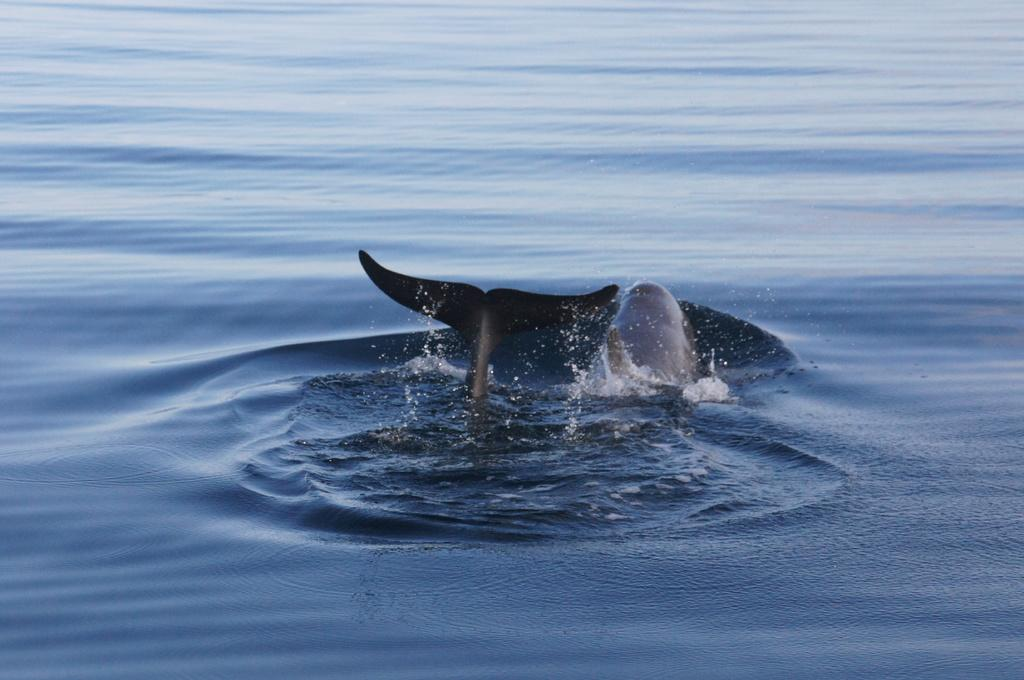What type of animal can be seen in the water in the image? There is a shark in the water in the image. What type of tub can be seen in the image? There is no tub present in the image; it features a shark in the water. Can you spot any deer in the image? There are no deer present in the image; it features a shark in the water. 